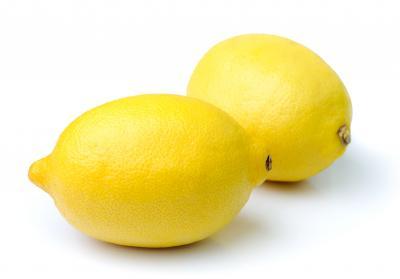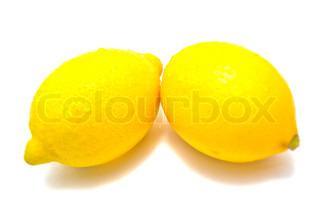The first image is the image on the left, the second image is the image on the right. Examine the images to the left and right. Is the description "There is one half of a lemon in one of the images." accurate? Answer yes or no. No. 